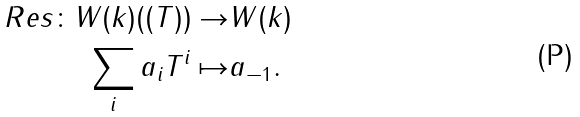<formula> <loc_0><loc_0><loc_500><loc_500>R e s \colon W ( k ) ( ( T ) ) \to & W ( k ) \\ \sum _ { i } a _ { i } T ^ { i } \mapsto & a _ { - 1 } .</formula> 